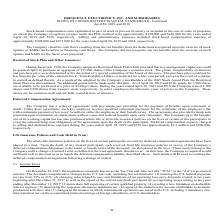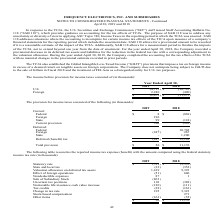According to Frequency Electronics's financial document, When was the Tax Cuts and Jobs Act enacted into law? According to the financial document, December 22, 2017. The relevant text states: "ollowing a change of control. 13. Income Taxes On December 22, 2017, the legislation commonly known as the Tax Cuts and Jobs Act (the “TCJA” or the “Act”) was enacted..." Also, What is the total current provision for 2019 and 2018 respectively? The document shows two values: 303 and (993) (in thousands). From the document: "Current provision 303 (993) Current provision 303 (993)..." Also, What is the total provision for 2019 and 2018 respectively? The document shows two values: $56 and $11,176 (in thousands). From the document: "Total provision $ 56 $ 11,176 Total provision $ 56 $ 11,176..." Also, can you calculate: What is the change in total provision between 2018 and 2019? Based on the calculation: 56-11,176, the result is -11120 (in thousands). This is based on the information: "Total provision $ 56 $ 11,176 Total provision $ 56 $ 11,176..." The key data points involved are: 11,176, 56. Also, can you calculate: What is the average current provision for 2018 and 2019? To answer this question, I need to perform calculations using the financial data. The calculation is: (303+(993))/2, which equals -345 (in thousands). This is based on the information: "Current provision 303 (993) 2019 and 2018 the Company issued 1,100 shares and 2,850 shares from treasury stock, respectively, to select employees for milestone years of service to Current provision 30..." The key data points involved are: 2, 303, 993. Also, can you calculate: In 2019, what is the percentage constitution of the current provision for foreign taxes among the total current provision? Based on the calculation: 196/303, the result is 64.69 (percentage). This is based on the information: "Foreign 196 - State 99 (124) Current provision 303 (993)..." The key data points involved are: 196, 303. 